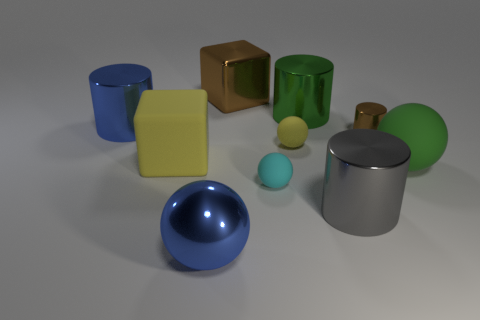There is a big shiny ball; is its color the same as the big cylinder left of the shiny sphere?
Your answer should be very brief. Yes. Does the big cube that is behind the tiny shiny thing have the same color as the small cylinder?
Provide a short and direct response. Yes. Are there any metal cylinders that have the same color as the metal cube?
Offer a very short reply. Yes. What color is the sphere in front of the tiny cyan matte thing that is in front of the green metallic thing?
Ensure brevity in your answer.  Blue. Does the tiny metal cylinder have the same color as the shiny cube?
Offer a terse response. Yes. What material is the tiny object that is in front of the yellow object left of the small cyan matte ball made of?
Provide a short and direct response. Rubber. What material is the tiny object that is the same shape as the big gray thing?
Your response must be concise. Metal. Are there any brown metal objects that are in front of the sphere to the left of the small sphere that is in front of the green matte sphere?
Keep it short and to the point. No. How many other things are the same color as the small metallic cylinder?
Give a very brief answer. 1. What number of objects are in front of the brown shiny cylinder and to the right of the large gray metallic cylinder?
Your answer should be very brief. 1. 